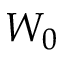<formula> <loc_0><loc_0><loc_500><loc_500>W _ { 0 }</formula> 